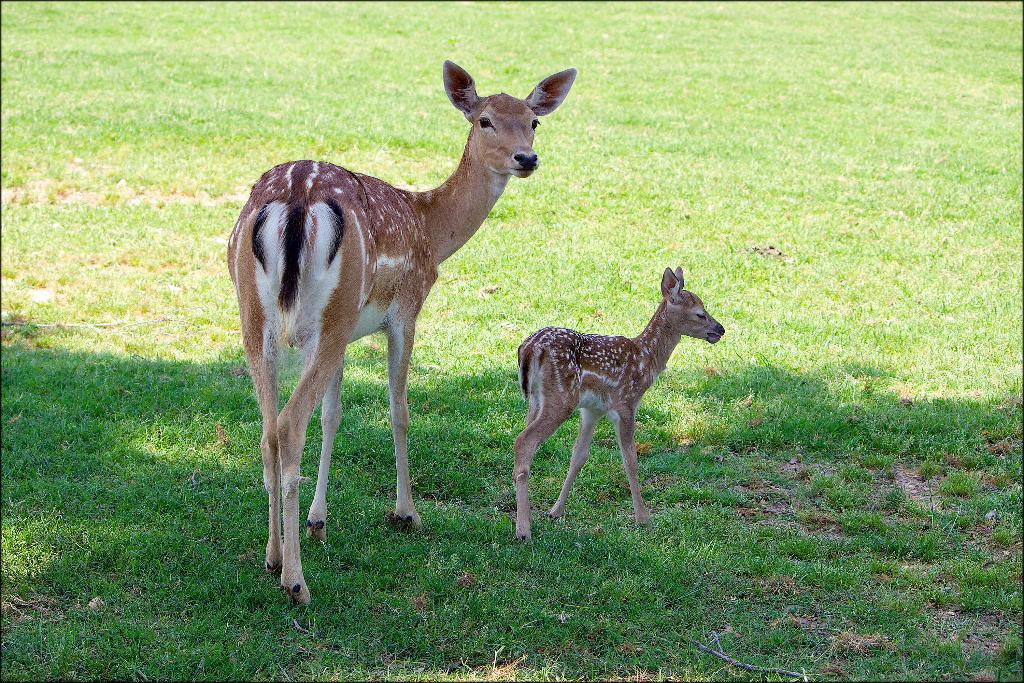What animals can be seen in the image? There are two deer in the image. Where are the deer located? The deer are on the ground. What type of vegetation is visible in the background of the image? There is grass visible in the background of the image. How many friends are swimming in the sea in the image? There are no friends or sea present in the image; it features two deer on the ground. What type of metal can be seen in the image? There is no metal, including zinc, present in the image. 